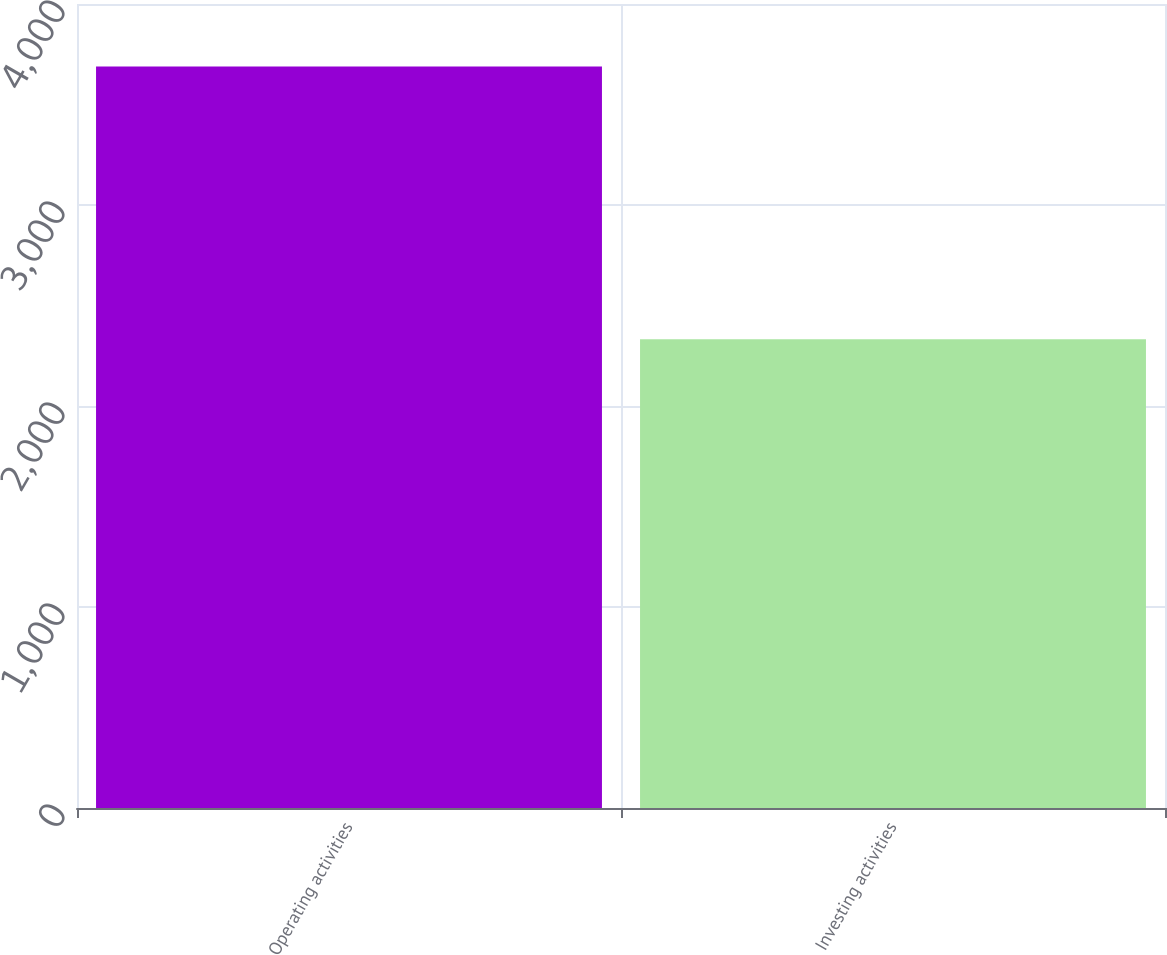Convert chart. <chart><loc_0><loc_0><loc_500><loc_500><bar_chart><fcel>Operating activities<fcel>Investing activities<nl><fcel>3689<fcel>2332<nl></chart> 